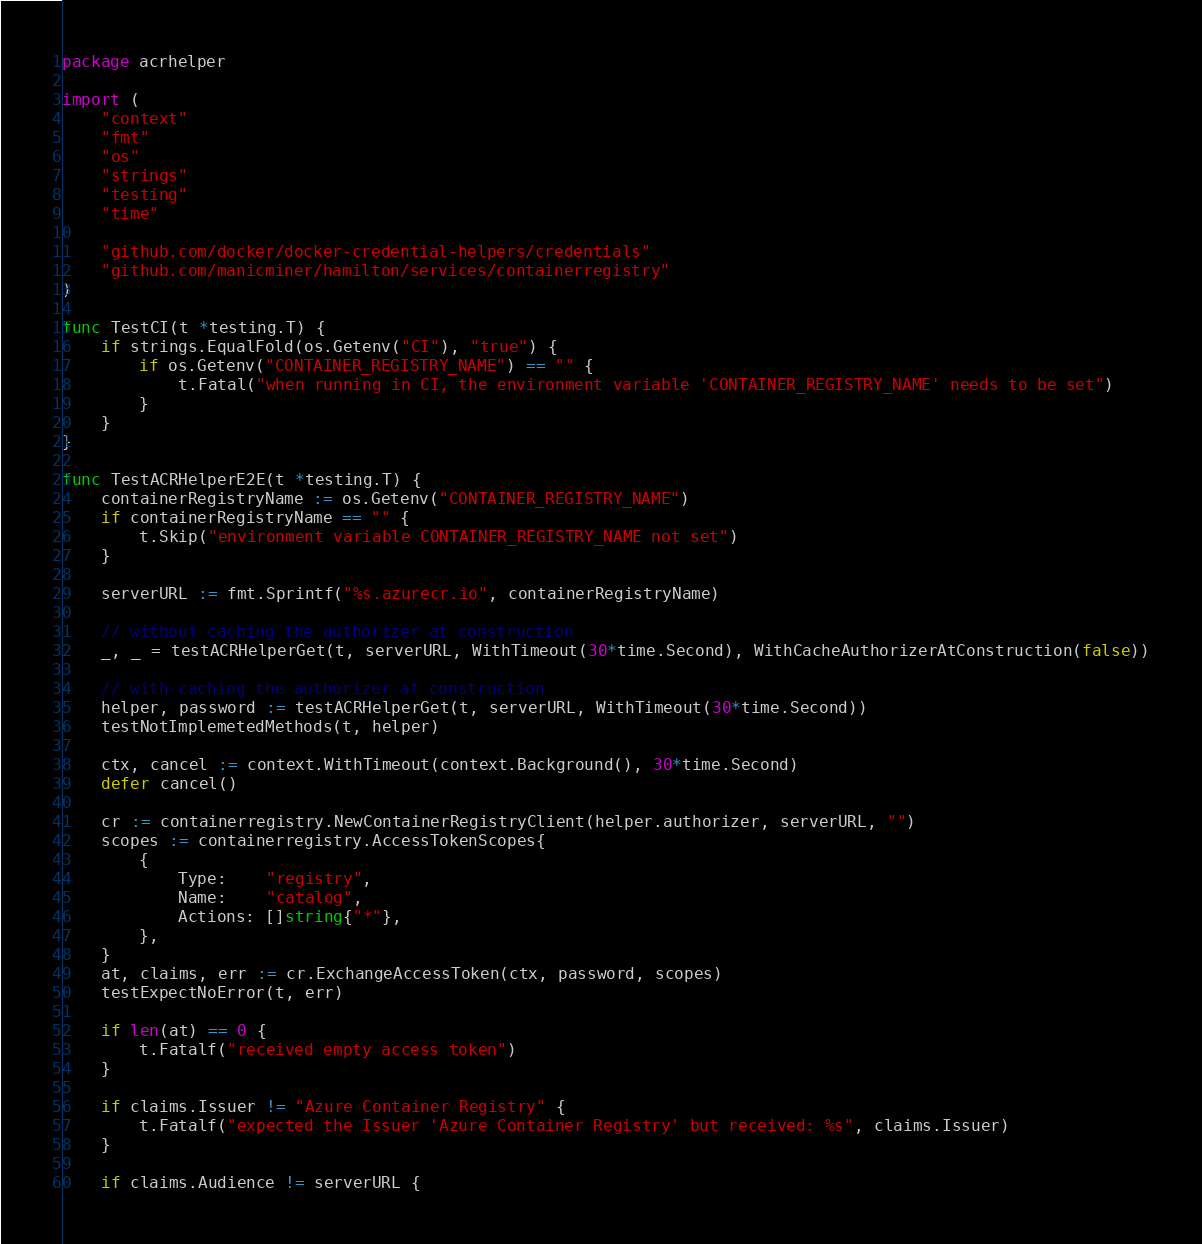Convert code to text. <code><loc_0><loc_0><loc_500><loc_500><_Go_>package acrhelper

import (
	"context"
	"fmt"
	"os"
	"strings"
	"testing"
	"time"

	"github.com/docker/docker-credential-helpers/credentials"
	"github.com/manicminer/hamilton/services/containerregistry"
)

func TestCI(t *testing.T) {
	if strings.EqualFold(os.Getenv("CI"), "true") {
		if os.Getenv("CONTAINER_REGISTRY_NAME") == "" {
			t.Fatal("when running in CI, the environment variable 'CONTAINER_REGISTRY_NAME' needs to be set")
		}
	}
}

func TestACRHelperE2E(t *testing.T) {
	containerRegistryName := os.Getenv("CONTAINER_REGISTRY_NAME")
	if containerRegistryName == "" {
		t.Skip("environment variable CONTAINER_REGISTRY_NAME not set")
	}

	serverURL := fmt.Sprintf("%s.azurecr.io", containerRegistryName)

	// without caching the authorizer at construction
	_, _ = testACRHelperGet(t, serverURL, WithTimeout(30*time.Second), WithCacheAuthorizerAtConstruction(false))

	// with caching the authorizer at construction
	helper, password := testACRHelperGet(t, serverURL, WithTimeout(30*time.Second))
	testNotImplemetedMethods(t, helper)

	ctx, cancel := context.WithTimeout(context.Background(), 30*time.Second)
	defer cancel()

	cr := containerregistry.NewContainerRegistryClient(helper.authorizer, serverURL, "")
	scopes := containerregistry.AccessTokenScopes{
		{
			Type:    "registry",
			Name:    "catalog",
			Actions: []string{"*"},
		},
	}
	at, claims, err := cr.ExchangeAccessToken(ctx, password, scopes)
	testExpectNoError(t, err)

	if len(at) == 0 {
		t.Fatalf("received empty access token")
	}

	if claims.Issuer != "Azure Container Registry" {
		t.Fatalf("expected the Issuer 'Azure Container Registry' but received: %s", claims.Issuer)
	}

	if claims.Audience != serverURL {</code> 